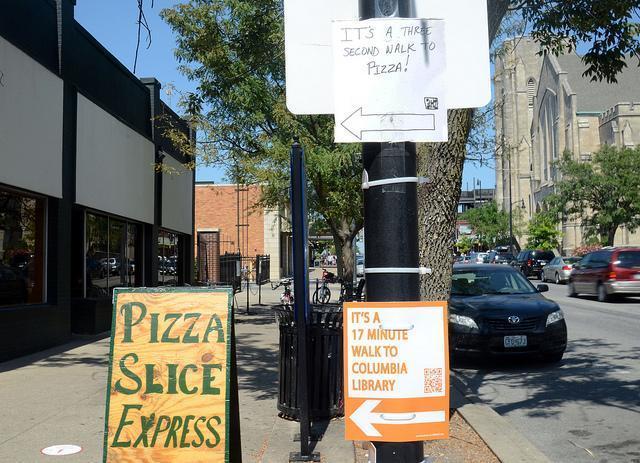How many cars are visible?
Give a very brief answer. 2. 